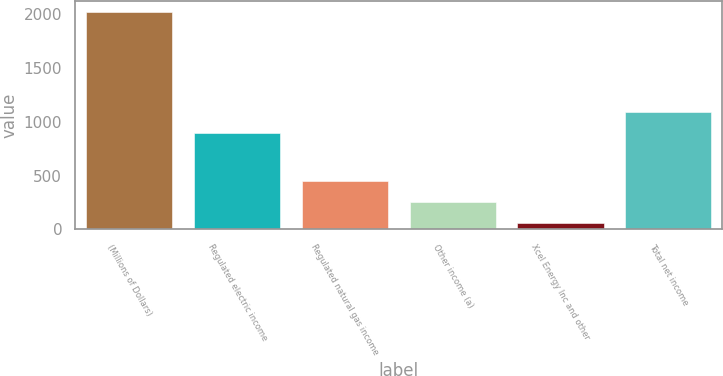Convert chart. <chart><loc_0><loc_0><loc_500><loc_500><bar_chart><fcel>(Millions of Dollars)<fcel>Regulated electric income<fcel>Regulated natural gas income<fcel>Other income (a)<fcel>Xcel Energy Inc and other<fcel>Total net income<nl><fcel>2014<fcel>890.5<fcel>448.64<fcel>252.97<fcel>57.3<fcel>1086.17<nl></chart> 